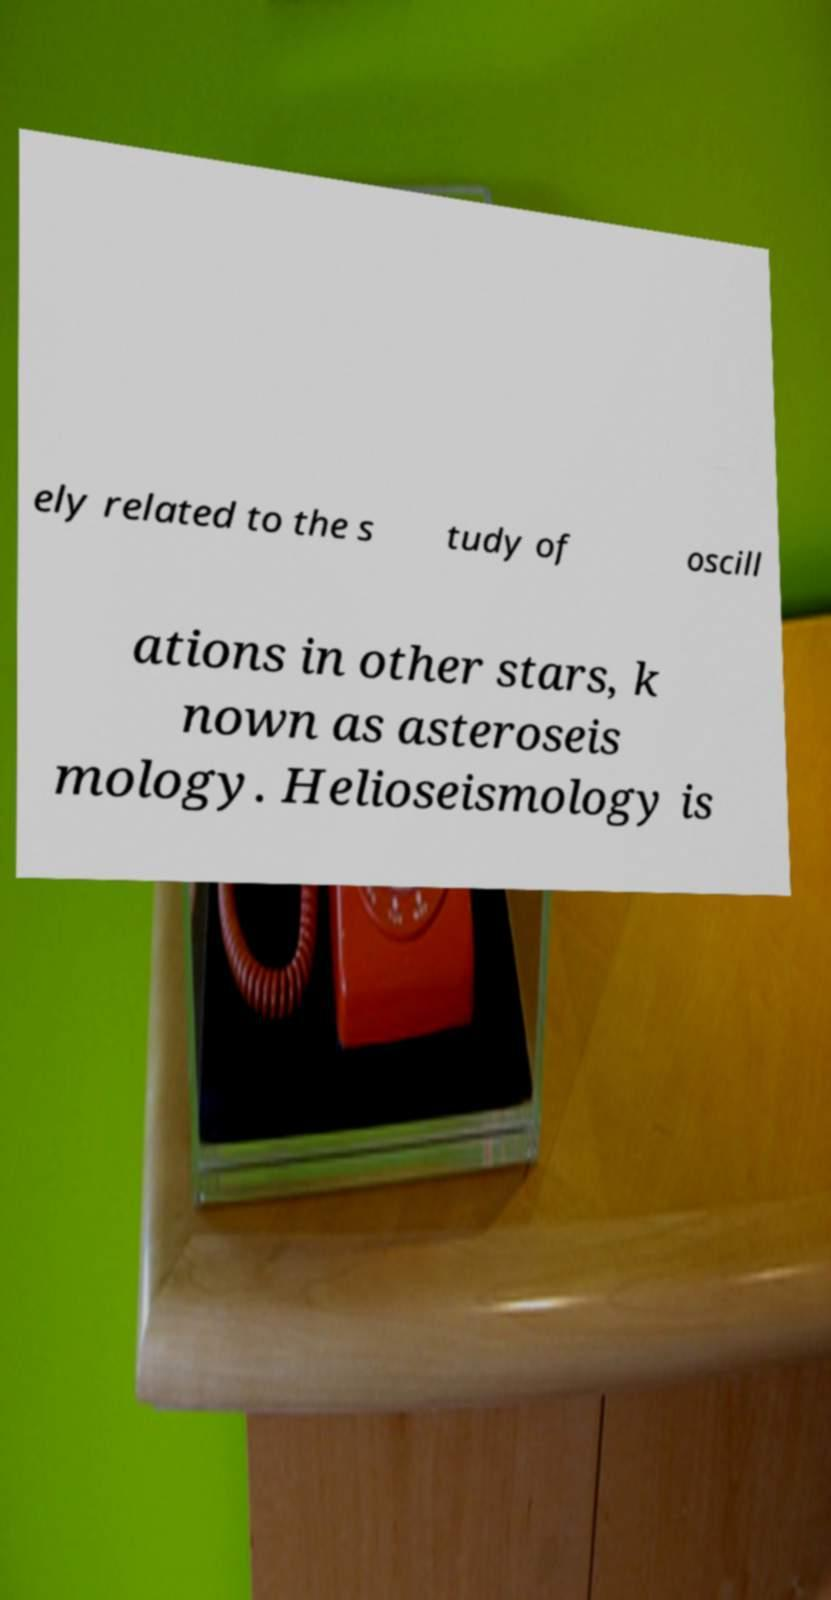Could you extract and type out the text from this image? ely related to the s tudy of oscill ations in other stars, k nown as asteroseis mology. Helioseismology is 